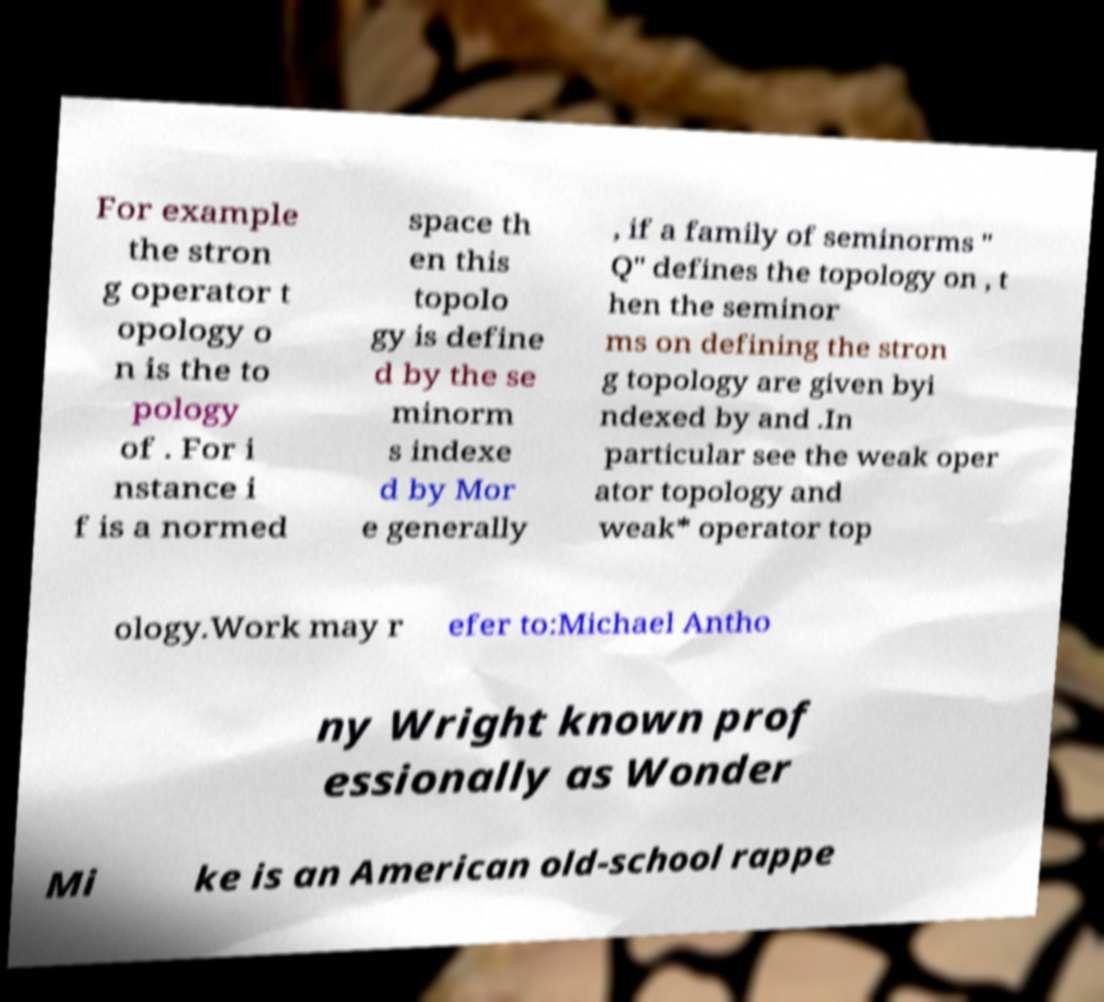There's text embedded in this image that I need extracted. Can you transcribe it verbatim? For example the stron g operator t opology o n is the to pology of . For i nstance i f is a normed space th en this topolo gy is define d by the se minorm s indexe d by Mor e generally , if a family of seminorms " Q" defines the topology on , t hen the seminor ms on defining the stron g topology are given byi ndexed by and .In particular see the weak oper ator topology and weak* operator top ology.Work may r efer to:Michael Antho ny Wright known prof essionally as Wonder Mi ke is an American old-school rappe 